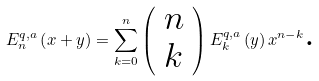<formula> <loc_0><loc_0><loc_500><loc_500>E _ { n } ^ { q , a } \left ( x + y \right ) = \sum _ { k = 0 } ^ { n } \left ( \begin{array} { l } n \\ k \end{array} \right ) E _ { k } ^ { q , a } \left ( y \right ) x ^ { n - k } \text {.}</formula> 